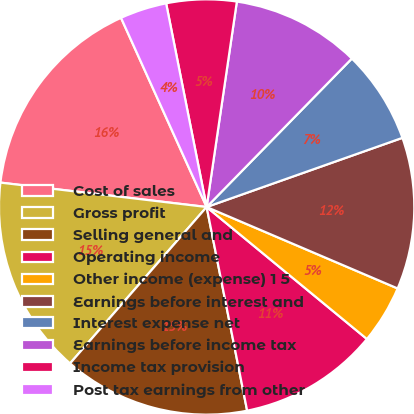<chart> <loc_0><loc_0><loc_500><loc_500><pie_chart><fcel>Cost of sales<fcel>Gross profit<fcel>Selling general and<fcel>Operating income<fcel>Other income (expense) 1 5<fcel>Earnings before interest and<fcel>Interest expense net<fcel>Earnings before income tax<fcel>Income tax provision<fcel>Post tax earnings from other<nl><fcel>16.36%<fcel>15.45%<fcel>14.55%<fcel>10.91%<fcel>4.55%<fcel>11.82%<fcel>7.27%<fcel>10.0%<fcel>5.45%<fcel>3.64%<nl></chart> 